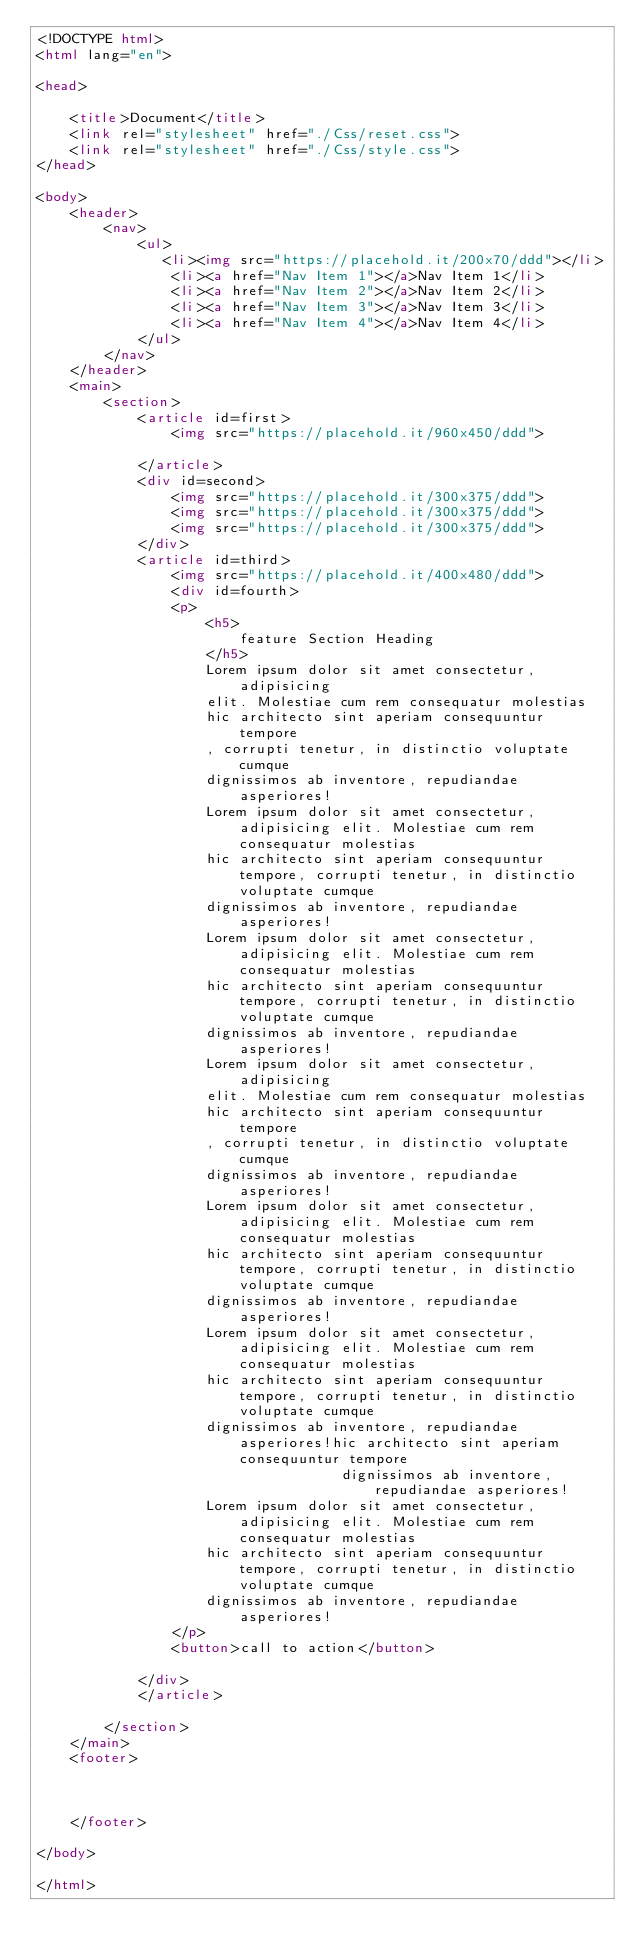Convert code to text. <code><loc_0><loc_0><loc_500><loc_500><_HTML_><!DOCTYPE html>
<html lang="en">

<head>

    <title>Document</title>
    <link rel="stylesheet" href="./Css/reset.css">
    <link rel="stylesheet" href="./Css/style.css">
</head>

<body>
    <header>
        <nav>
            <ul>
               <li><img src="https://placehold.it/200x70/ddd"></li> 
                <li><a href="Nav Item 1"></a>Nav Item 1</li>
                <li><a href="Nav Item 2"></a>Nav Item 2</li>
                <li><a href="Nav Item 3"></a>Nav Item 3</li>
                <li><a href="Nav Item 4"></a>Nav Item 4</li>
            </ul>
        </nav>
    </header>
    <main>
        <section>
            <article id=first>
                <img src="https://placehold.it/960x450/ddd">

            </article>
            <div id=second>
                <img src="https://placehold.it/300x375/ddd">
                <img src="https://placehold.it/300x375/ddd">
                <img src="https://placehold.it/300x375/ddd">
            </div>
            <article id=third>
                <img src="https://placehold.it/400x480/ddd">
                <div id=fourth>
                <p>
                    <h5>
                        feature Section Heading
                    </h5>
                    Lorem ipsum dolor sit amet consectetur, adipisicing 
                    elit. Molestiae cum rem consequatur molestias
                    hic architecto sint aperiam consequuntur tempore
                    , corrupti tenetur, in distinctio voluptate cumque
                    dignissimos ab inventore, repudiandae asperiores!
                    Lorem ipsum dolor sit amet consectetur, adipisicing elit. Molestiae cum rem consequatur molestias
                    hic architecto sint aperiam consequuntur tempore, corrupti tenetur, in distinctio voluptate cumque
                    dignissimos ab inventore, repudiandae asperiores!
                    Lorem ipsum dolor sit amet consectetur, adipisicing elit. Molestiae cum rem consequatur molestias
                    hic architecto sint aperiam consequuntur tempore, corrupti tenetur, in distinctio voluptate cumque
                    dignissimos ab inventore, repudiandae asperiores!
                    Lorem ipsum dolor sit amet consectetur, adipisicing 
                    elit. Molestiae cum rem consequatur molestias
                    hic architecto sint aperiam consequuntur tempore
                    , corrupti tenetur, in distinctio voluptate cumque
                    dignissimos ab inventore, repudiandae asperiores!
                    Lorem ipsum dolor sit amet consectetur, adipisicing elit. Molestiae cum rem consequatur molestias
                    hic architecto sint aperiam consequuntur tempore, corrupti tenetur, in distinctio voluptate cumque
                    dignissimos ab inventore, repudiandae asperiores!
                    Lorem ipsum dolor sit amet consectetur, adipisicing elit. Molestiae cum rem consequatur molestias
                    hic architecto sint aperiam consequuntur tempore, corrupti tenetur, in distinctio voluptate cumque
                    dignissimos ab inventore, repudiandae asperiores!hic architecto sint aperiam consequuntur tempore
                                    dignissimos ab inventore, repudiandae asperiores!
                    Lorem ipsum dolor sit amet consectetur, adipisicing elit. Molestiae cum rem consequatur molestias
                    hic architecto sint aperiam consequuntur tempore, corrupti tenetur, in distinctio voluptate cumque
                    dignissimos ab inventore, repudiandae asperiores!
                </p>
                <button>call to action</button>
                
            </div>
            </article>

        </section>
    </main>
    <footer>



    </footer>

</body>

</html></code> 